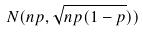Convert formula to latex. <formula><loc_0><loc_0><loc_500><loc_500>N ( n p , \sqrt { n p ( 1 - p } ) )</formula> 